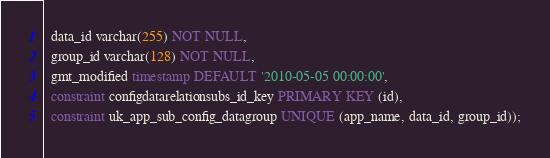Convert code to text. <code><loc_0><loc_0><loc_500><loc_500><_SQL_>  data_id varchar(255) NOT NULL,
  group_id varchar(128) NOT NULL,
  gmt_modified timestamp DEFAULT '2010-05-05 00:00:00',
  constraint configdatarelationsubs_id_key PRIMARY KEY (id),
  constraint uk_app_sub_config_datagroup UNIQUE (app_name, data_id, group_id));

</code> 